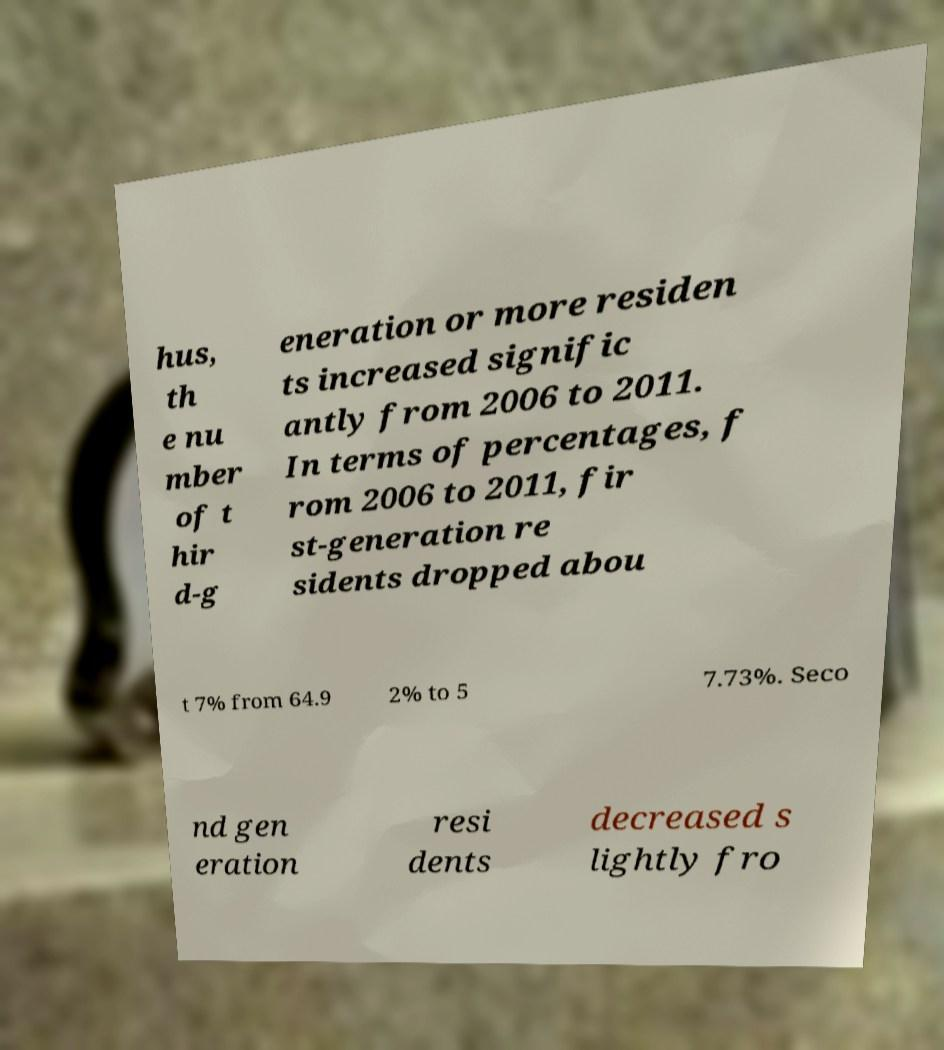Please identify and transcribe the text found in this image. hus, th e nu mber of t hir d-g eneration or more residen ts increased signific antly from 2006 to 2011. In terms of percentages, f rom 2006 to 2011, fir st-generation re sidents dropped abou t 7% from 64.9 2% to 5 7.73%. Seco nd gen eration resi dents decreased s lightly fro 